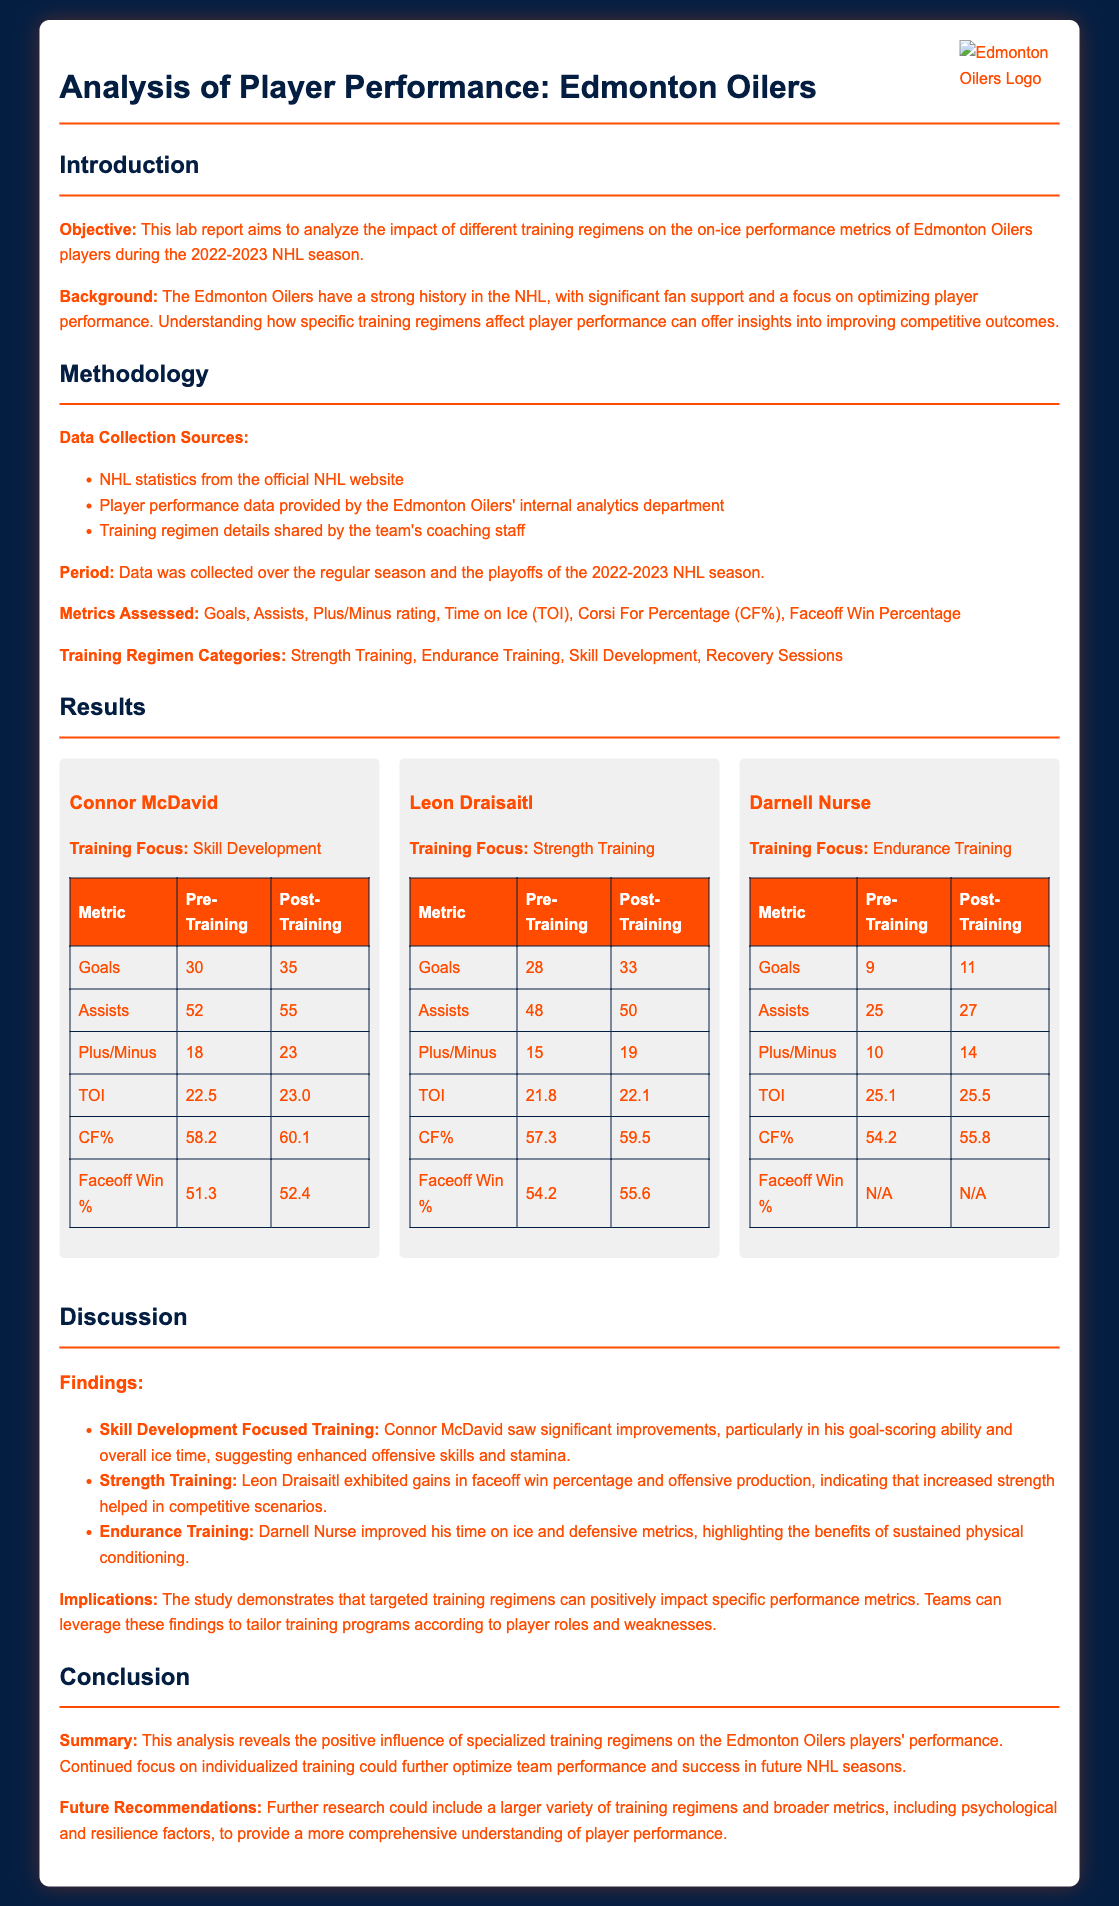What is the objective of the lab report? The objective is to analyze the impact of different training regimens on the on-ice performance metrics of Edmonton Oilers players during the 2022-2023 NHL season.
Answer: Analyze the impact of different training regimens What training focus did Connor McDavid have? Connor McDavid's training focus was on Skill Development.
Answer: Skill Development What was Leon Draisaitl's goals pre-training? The number of goals Leon Draisaitl had pre-training was 28.
Answer: 28 What improvement did Darnell Nurse see in Plus/Minus rating post-training? Darnell Nurse's Plus/Minus rating improved from 10 to 14, which is an increase of 4.
Answer: 4 Which performance metric showed the most improvement for Connor McDavid? The most improvement for Connor McDavid was in goals, increasing from 30 to 35.
Answer: Goals How did faceoff win percentage change for Leon Draisaitl? Leon Draisaitl's faceoff win percentage increased from 54.2 to 55.6 after training.
Answer: Increased What implication does the study suggest regarding player training? The study suggests that targeted training regimens can positively impact specific performance metrics.
Answer: Targeted training regimens What does the report recommend for future research? The report recommends including a larger variety of training regimens and broader metrics for future research.
Answer: Larger variety of training regimens 